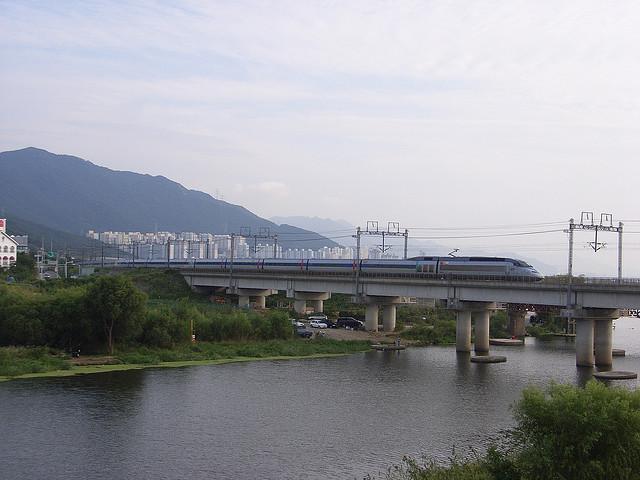How many pillars support the bridge?
Give a very brief answer. 10. 